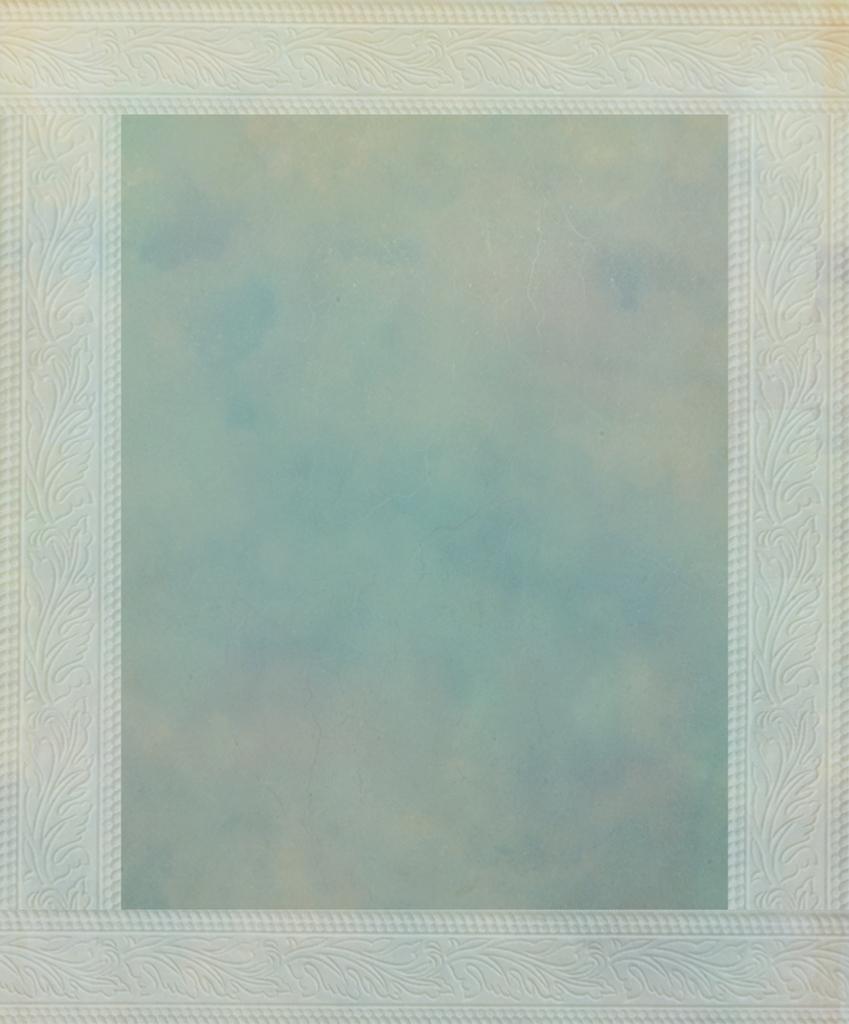In one or two sentences, can you explain what this image depicts? In this image we can see a frame with sky. 